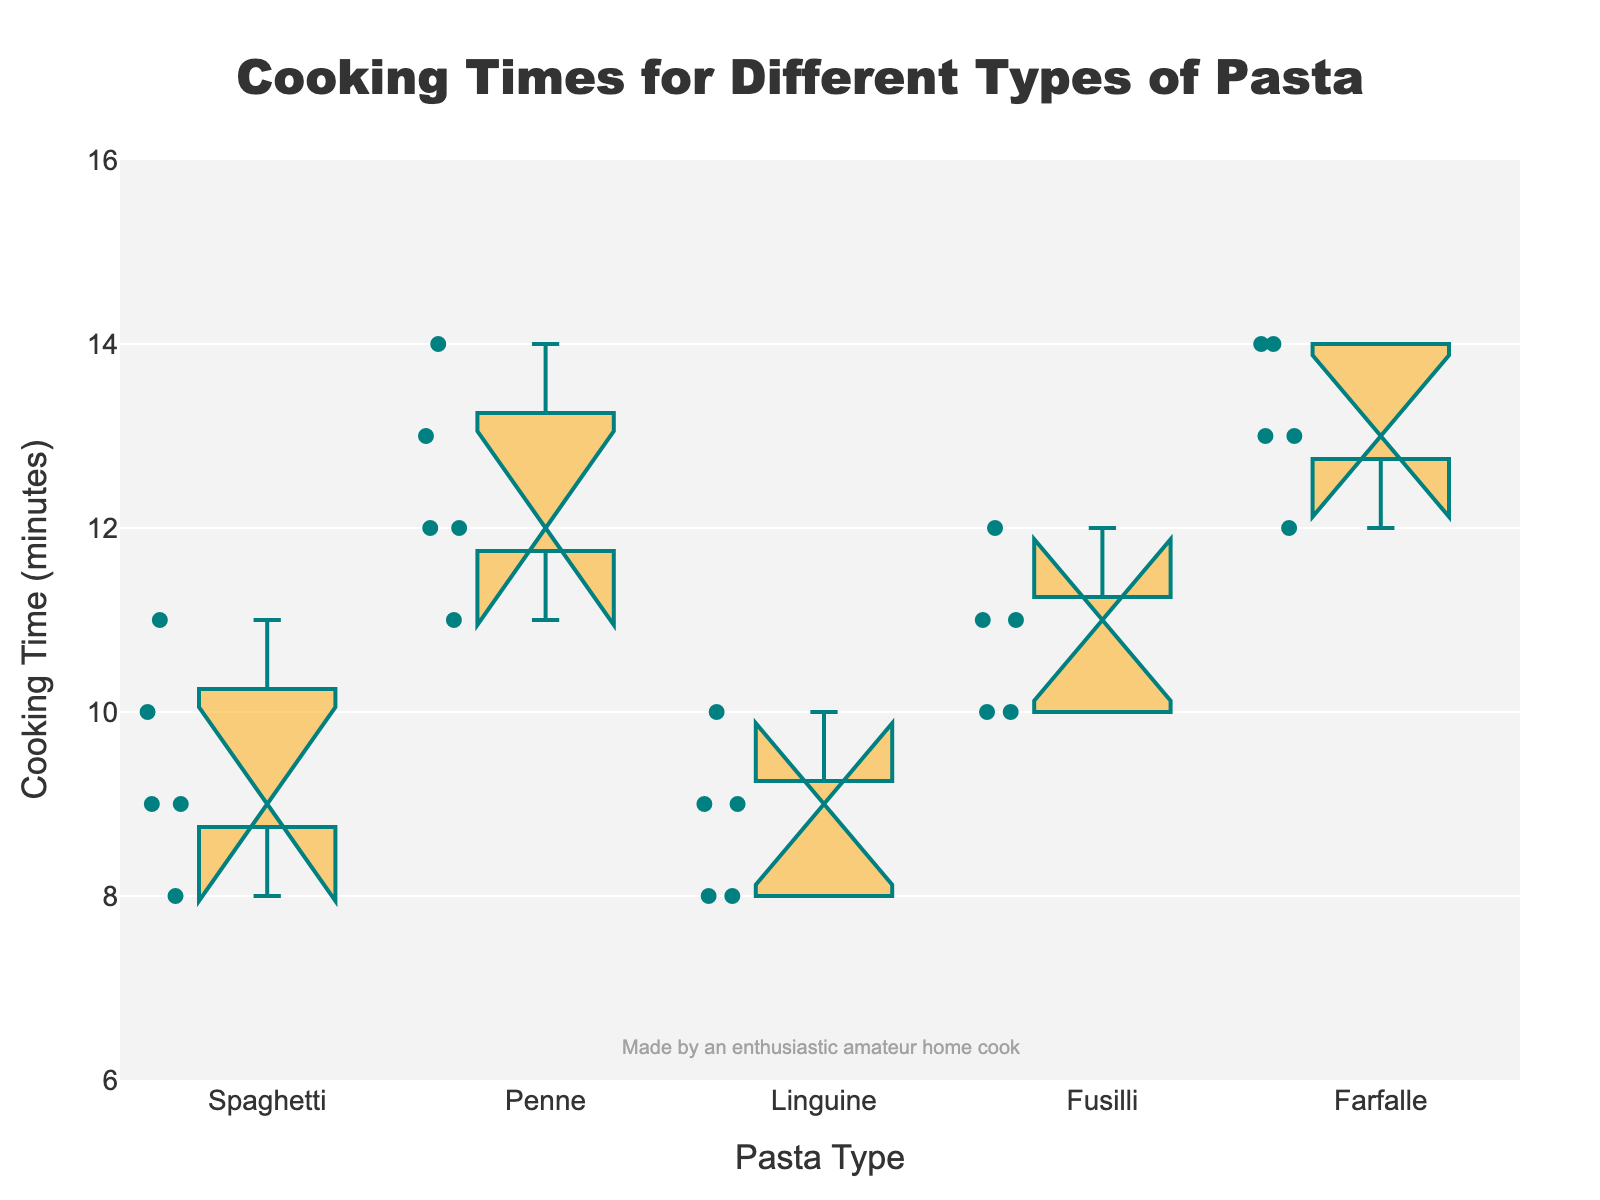What is the title of the plot? The title is located at the top of the plot and is usually larger and more prominent in size than other text elements.
Answer: Cooking Times for Different Types of Pasta What are the labels for the x-axis and y-axis? These labels are positioned next to the respective axes. The x-axis label is typically located below the horizontal axis, and the y-axis label is situated to the left of the vertical axis.
Answer: Pasta Type; Cooking Time (minutes) Which pasta type has the highest median cooking time? By examining the center line within the notched part of the boxes, we can determine the median value for each pasta type. The highest median will be the one that is the most elevated.
Answer: Farfalle What is the interquartile range (IQR) for Spaghetti? The IQR is the range between the first quartile (bottom of the box) and the third quartile (top of the box). To find the IQR, look at the height of the box for Spaghetti.
Answer: 2 Between Penne and Fusilli, which type has a wider range of cooking times? The range is the difference between the maximum and minimum values, indicated by the whiskers of each box. Compare the length of the whiskers for Penne and Fusilli.
Answer: Penne Are there any outliers in the cooking time data? Outliers are shown using individual points that fall outside the whiskers on a box plot. By scanning the plot, you can check if any datapoints are noticeably detached from the whiskers.
Answer: No Which pasta type shows the most variation in cooking times? Variation in cooking times can be inferred from the height of the box (IQR) and the length of the whiskers. The most varied will have the largest boxes and/or whiskers.
Answer: Penne What is the median cooking time for Linguine? The median is represented by the line within the notch of the box for Linguine.
Answer: 9 Which pasta types have overlapping notches? In a notched box plot, overlapping notches between two boxes indicate that their medians are not significantly different. Scan for any notches that overlap horizontally.
Answer: Spaghetti and Linguine; Fusilli and Penne 